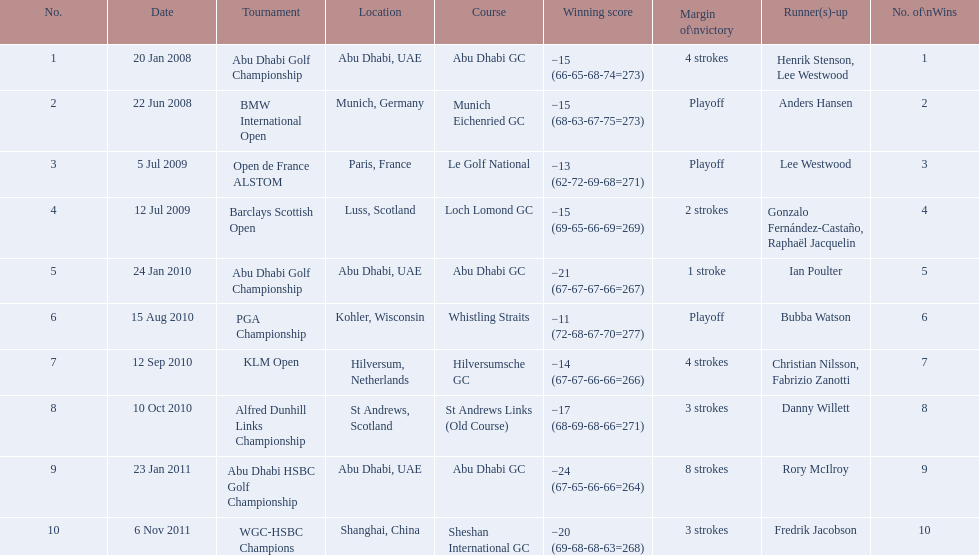Which tournaments did martin kaymer participate in? Abu Dhabi Golf Championship, BMW International Open, Open de France ALSTOM, Barclays Scottish Open, Abu Dhabi Golf Championship, PGA Championship, KLM Open, Alfred Dunhill Links Championship, Abu Dhabi HSBC Golf Championship, WGC-HSBC Champions. How many of these tournaments were won through a playoff? BMW International Open, Open de France ALSTOM, PGA Championship. Which of those tournaments took place in 2010? PGA Championship. Who had to top score next to martin kaymer for that tournament? Bubba Watson. 